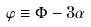Convert formula to latex. <formula><loc_0><loc_0><loc_500><loc_500>\varphi \equiv \Phi - 3 \alpha</formula> 